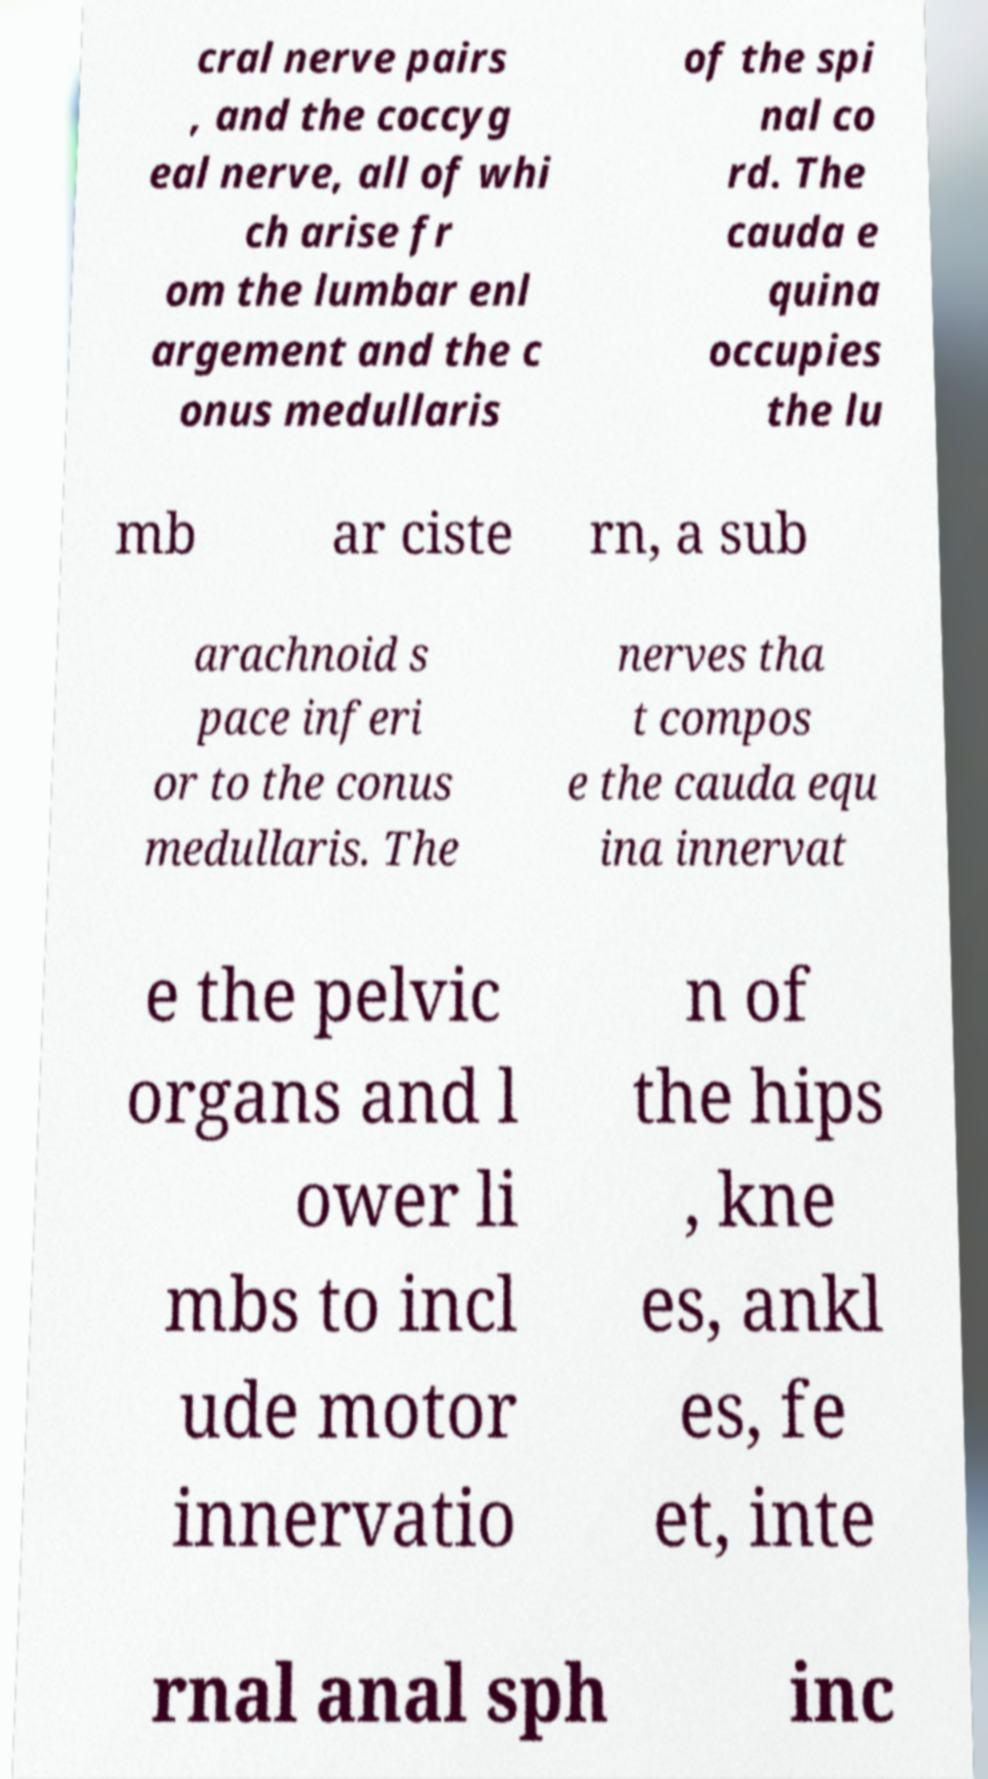What messages or text are displayed in this image? I need them in a readable, typed format. cral nerve pairs , and the coccyg eal nerve, all of whi ch arise fr om the lumbar enl argement and the c onus medullaris of the spi nal co rd. The cauda e quina occupies the lu mb ar ciste rn, a sub arachnoid s pace inferi or to the conus medullaris. The nerves tha t compos e the cauda equ ina innervat e the pelvic organs and l ower li mbs to incl ude motor innervatio n of the hips , kne es, ankl es, fe et, inte rnal anal sph inc 